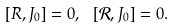Convert formula to latex. <formula><loc_0><loc_0><loc_500><loc_500>[ R , J _ { 0 } ] = 0 , \, \ [ { \mathcal { R } } , J _ { 0 } ] = 0 .</formula> 